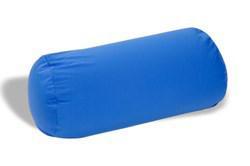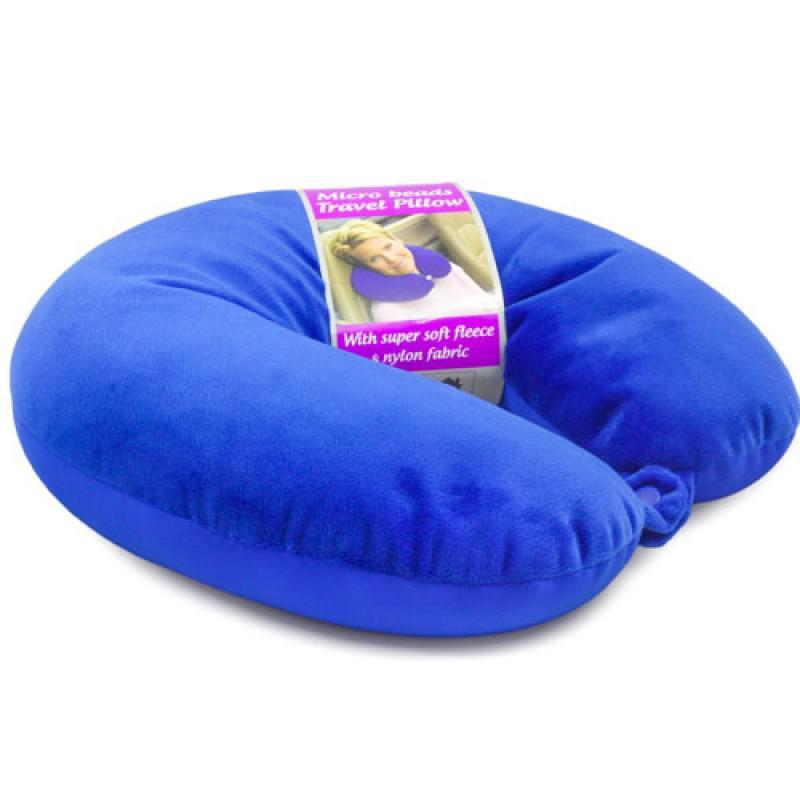The first image is the image on the left, the second image is the image on the right. For the images displayed, is the sentence "The left image has a neck pillow in a cylindrical shape." factually correct? Answer yes or no. Yes. The first image is the image on the left, the second image is the image on the right. Given the left and right images, does the statement "The left image contains one oblong blue pillow, and the right image includes a bright blue horseshoe-shaped pillow." hold true? Answer yes or no. Yes. 